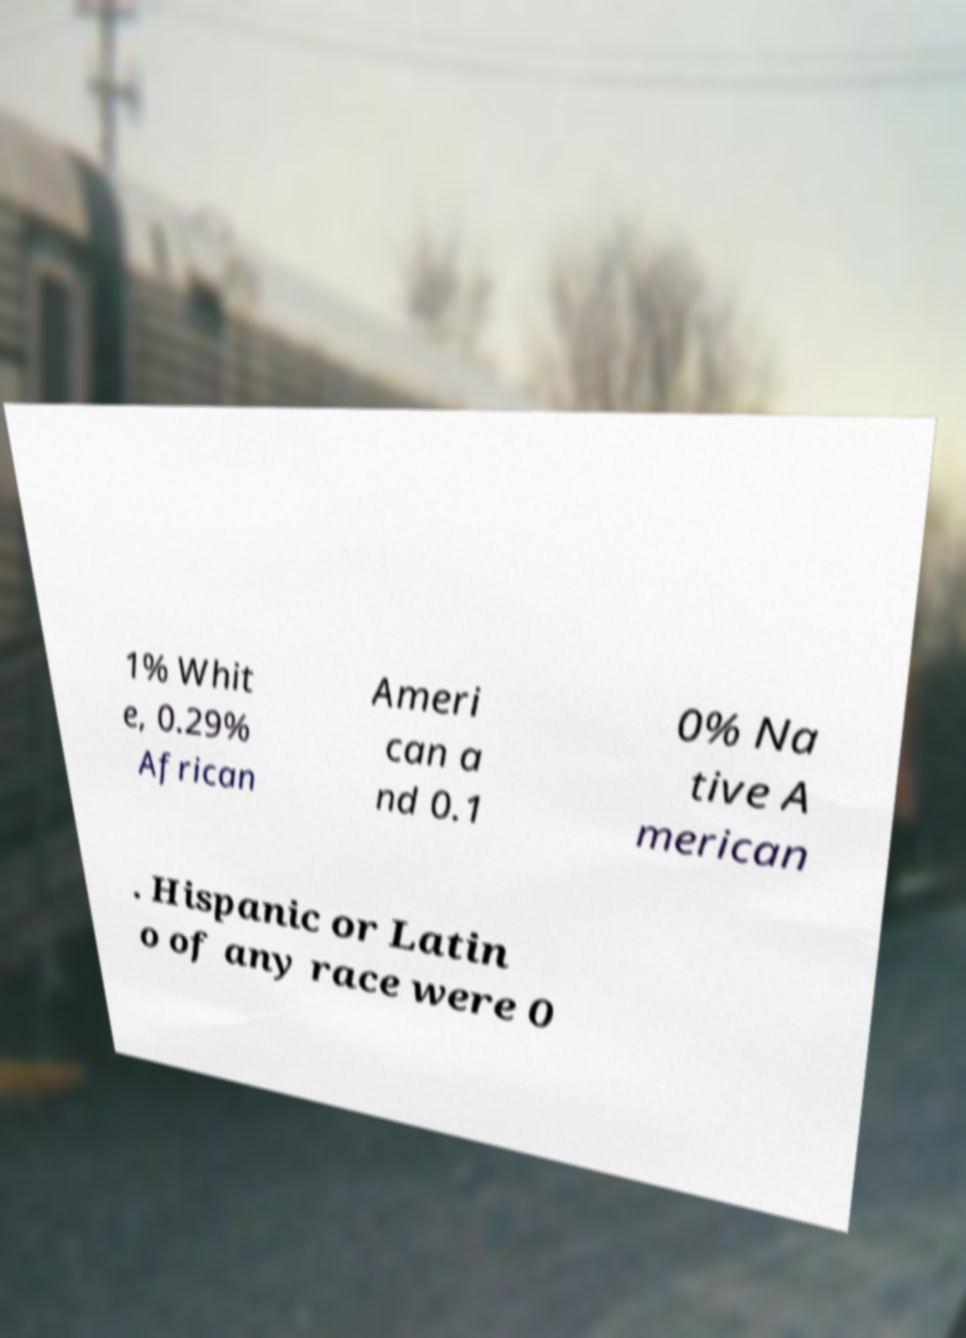I need the written content from this picture converted into text. Can you do that? 1% Whit e, 0.29% African Ameri can a nd 0.1 0% Na tive A merican . Hispanic or Latin o of any race were 0 